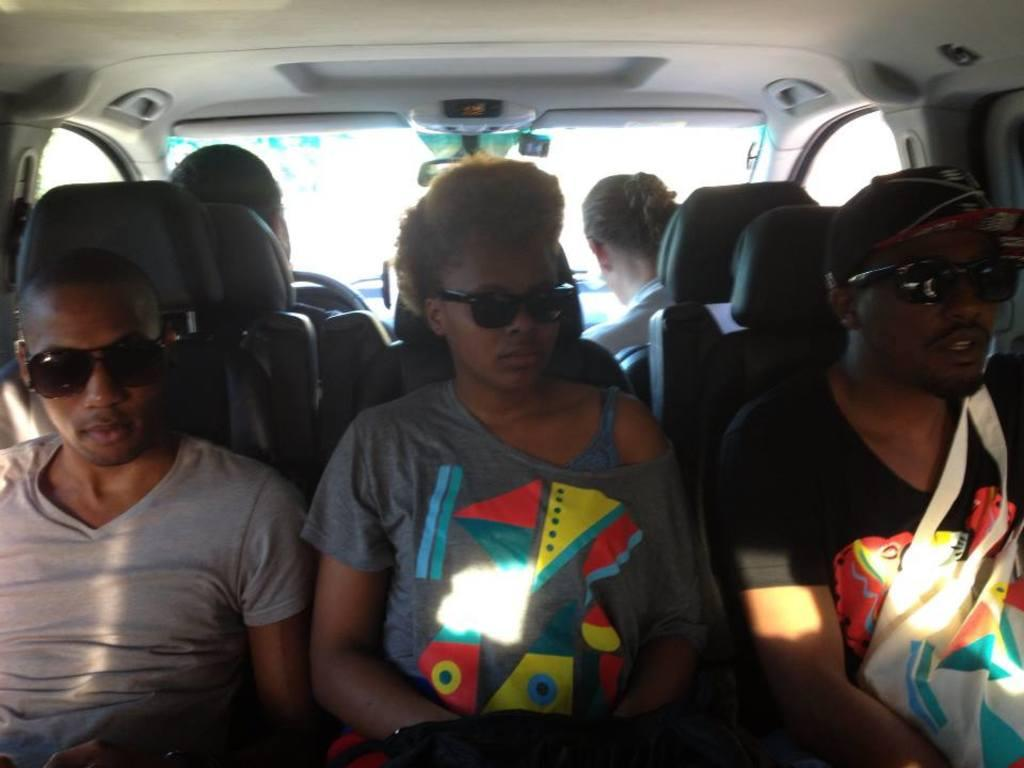What are the people in the image doing? The persons in the image are sitting on chairs. Where was the image taken from? The image was taken from inside a vehicle. What can be seen in the background of the image? There is a glass visible in the background of the image. How many cacti can be seen in the image? There are no cacti present in the image. What type of curve is visible in the image? There is no curve visible in the image. 